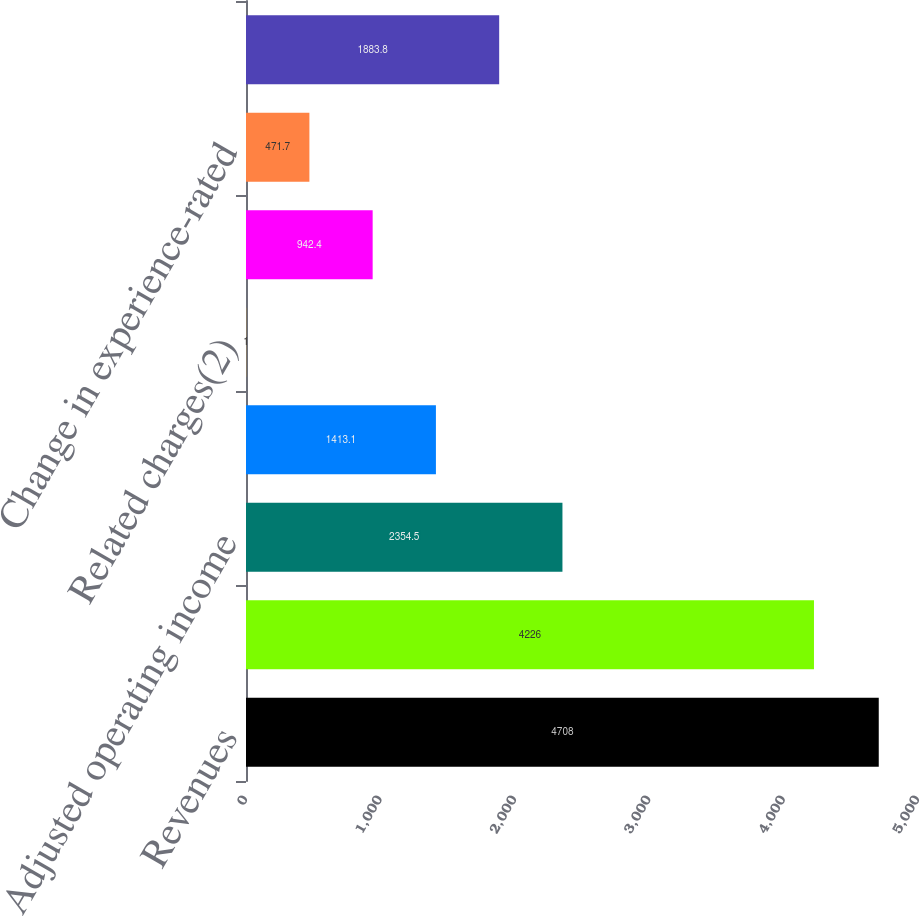<chart> <loc_0><loc_0><loc_500><loc_500><bar_chart><fcel>Revenues<fcel>Benefits and expenses<fcel>Adjusted operating income<fcel>Realized investment gains<fcel>Related charges(2)<fcel>Investment gains (losses) on<fcel>Change in experience-rated<fcel>Income (loss) from continuing<nl><fcel>4708<fcel>4226<fcel>2354.5<fcel>1413.1<fcel>1<fcel>942.4<fcel>471.7<fcel>1883.8<nl></chart> 